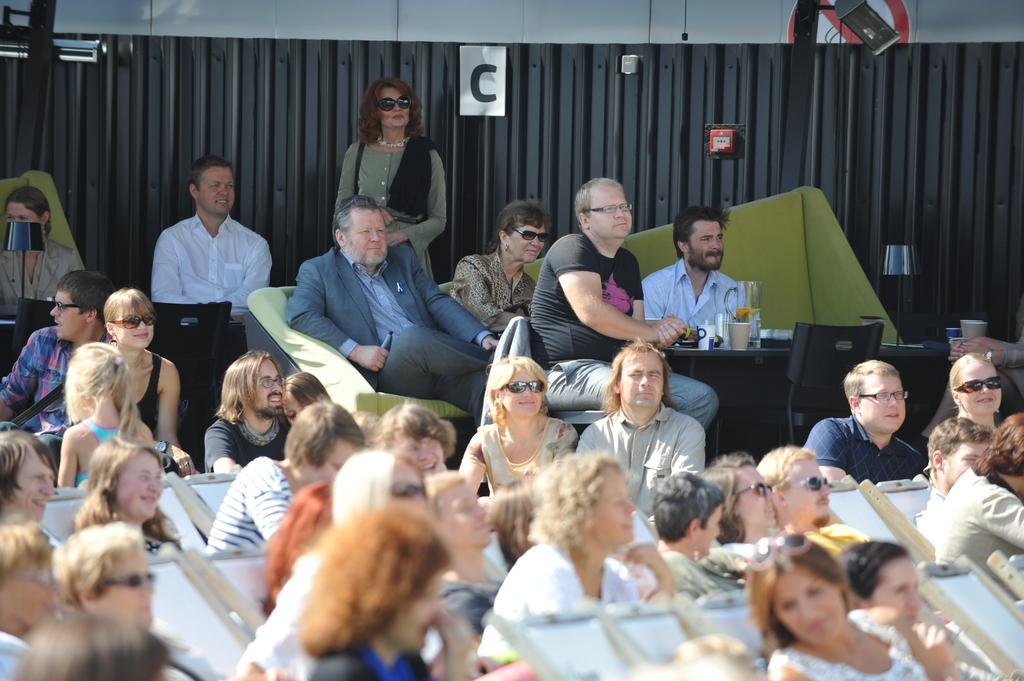Describe this image in one or two sentences. In this image I can see few people sitting on the chairs. I can see a glass and few objects on the table. Background is in black and grey color. 